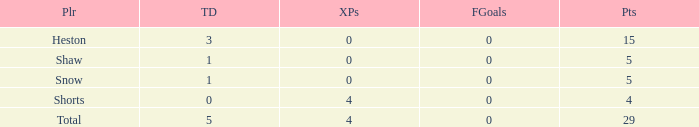What is the total number of field goals a player had when there were more than 0 extra points and there were 5 touchdowns? 1.0. Parse the table in full. {'header': ['Plr', 'TD', 'XPs', 'FGoals', 'Pts'], 'rows': [['Heston', '3', '0', '0', '15'], ['Shaw', '1', '0', '0', '5'], ['Snow', '1', '0', '0', '5'], ['Shorts', '0', '4', '0', '4'], ['Total', '5', '4', '0', '29']]} 